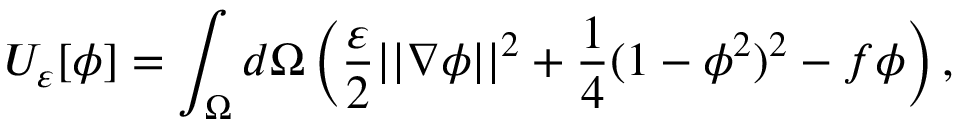Convert formula to latex. <formula><loc_0><loc_0><loc_500><loc_500>U _ { \varepsilon } [ \phi ] = \int _ { \Omega } d \Omega \left ( \frac { \varepsilon } { 2 } | | \nabla \phi | | ^ { 2 } + \frac { 1 } { 4 } ( 1 - \phi ^ { 2 } ) ^ { 2 } - f \phi \right ) ,</formula> 